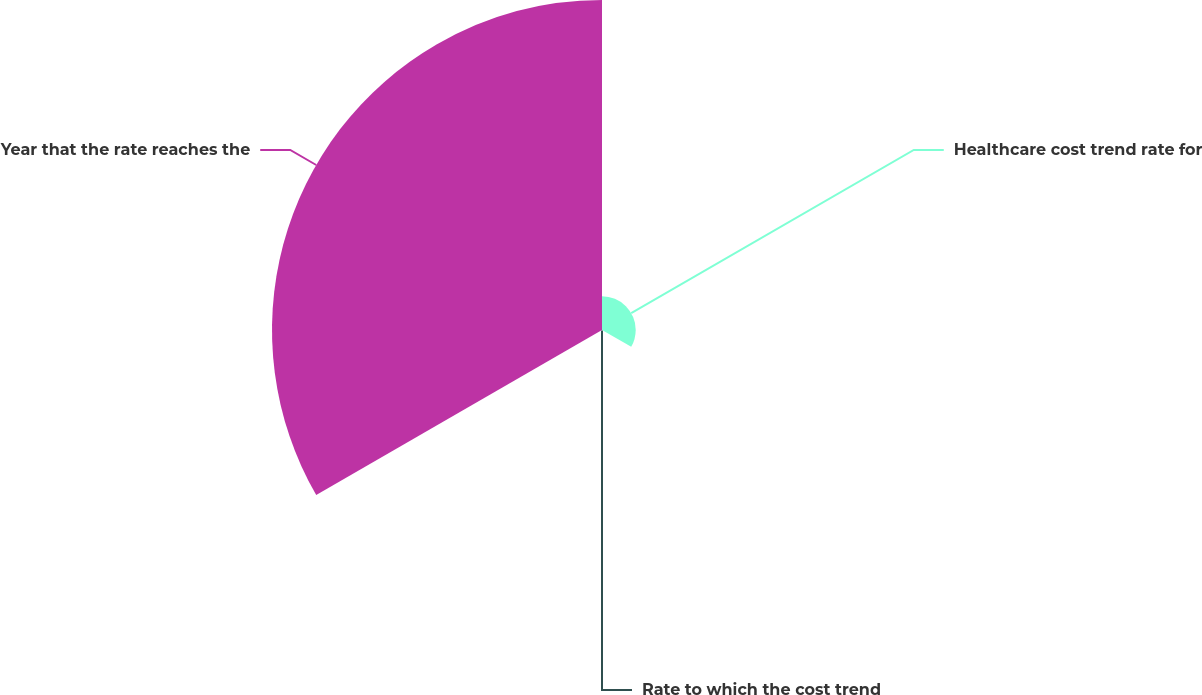<chart> <loc_0><loc_0><loc_500><loc_500><pie_chart><fcel>Healthcare cost trend rate for<fcel>Rate to which the cost trend<fcel>Year that the rate reaches the<nl><fcel>9.25%<fcel>0.22%<fcel>90.52%<nl></chart> 